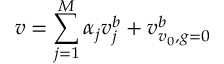<formula> <loc_0><loc_0><loc_500><loc_500>v = \sum _ { j = 1 } ^ { M } \alpha _ { j } v _ { j } ^ { b } + v _ { v _ { 0 } , g = 0 } ^ { b }</formula> 